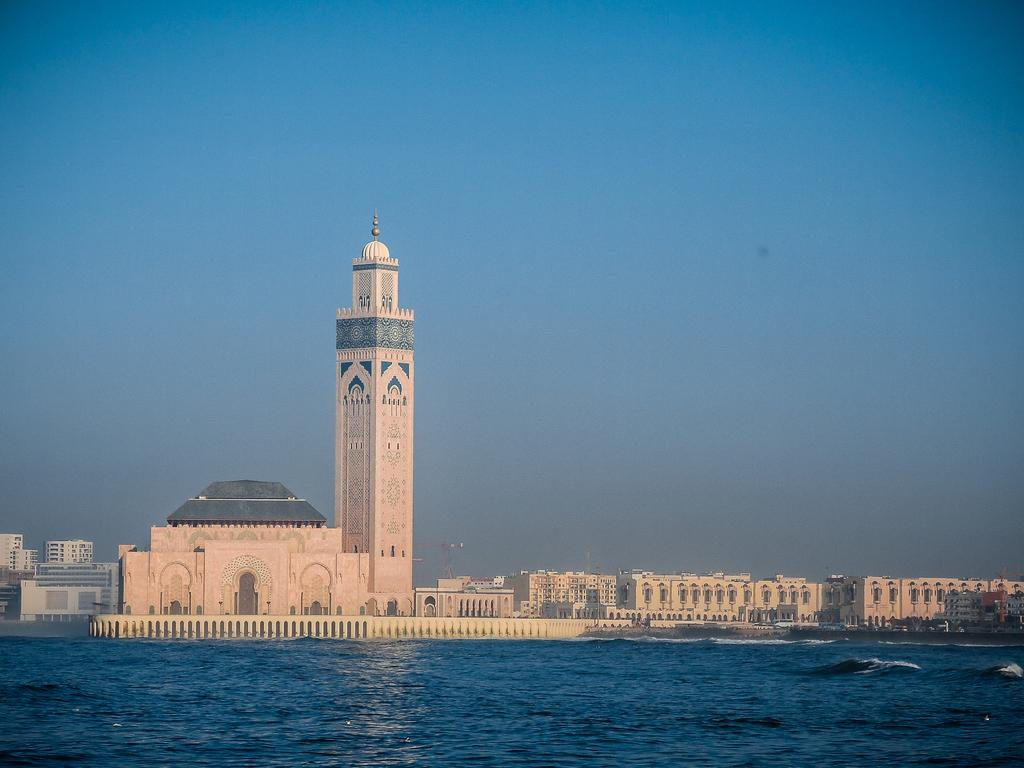What type of structures can be seen in the image? There are buildings in the image. What natural element is visible in the image? There is water visible in the image. What can be seen in the background of the image? The sky is visible in the background of the image. How many eggs are floating in the water in the image? There are no eggs visible in the image; it features buildings and water. 